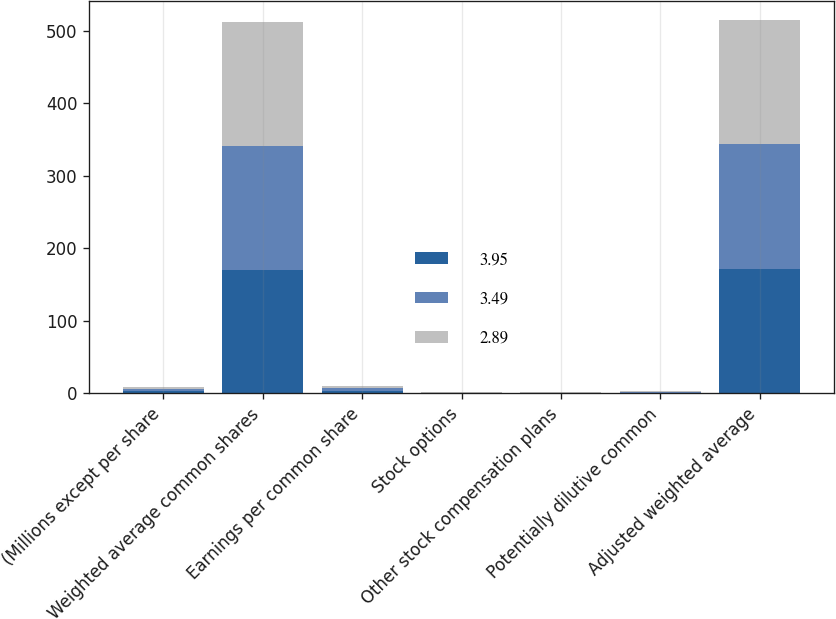<chart> <loc_0><loc_0><loc_500><loc_500><stacked_bar_chart><ecel><fcel>(Millions except per share<fcel>Weighted average common shares<fcel>Earnings per common share<fcel>Stock options<fcel>Other stock compensation plans<fcel>Potentially dilutive common<fcel>Adjusted weighted average<nl><fcel>3.95<fcel>2.91<fcel>169.6<fcel>3.49<fcel>0.6<fcel>0.7<fcel>1.3<fcel>170.9<nl><fcel>3.49<fcel>2.91<fcel>171.7<fcel>3.95<fcel>0.7<fcel>0.6<fcel>1.3<fcel>173<nl><fcel>2.89<fcel>2.91<fcel>169.9<fcel>2.89<fcel>0.2<fcel>0.8<fcel>1<fcel>170.9<nl></chart> 